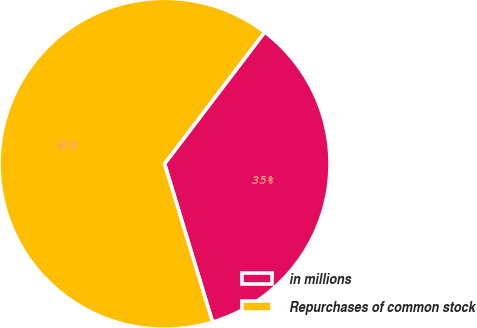Convert chart. <chart><loc_0><loc_0><loc_500><loc_500><pie_chart><fcel>in millions<fcel>Repurchases of common stock<nl><fcel>34.97%<fcel>65.03%<nl></chart> 